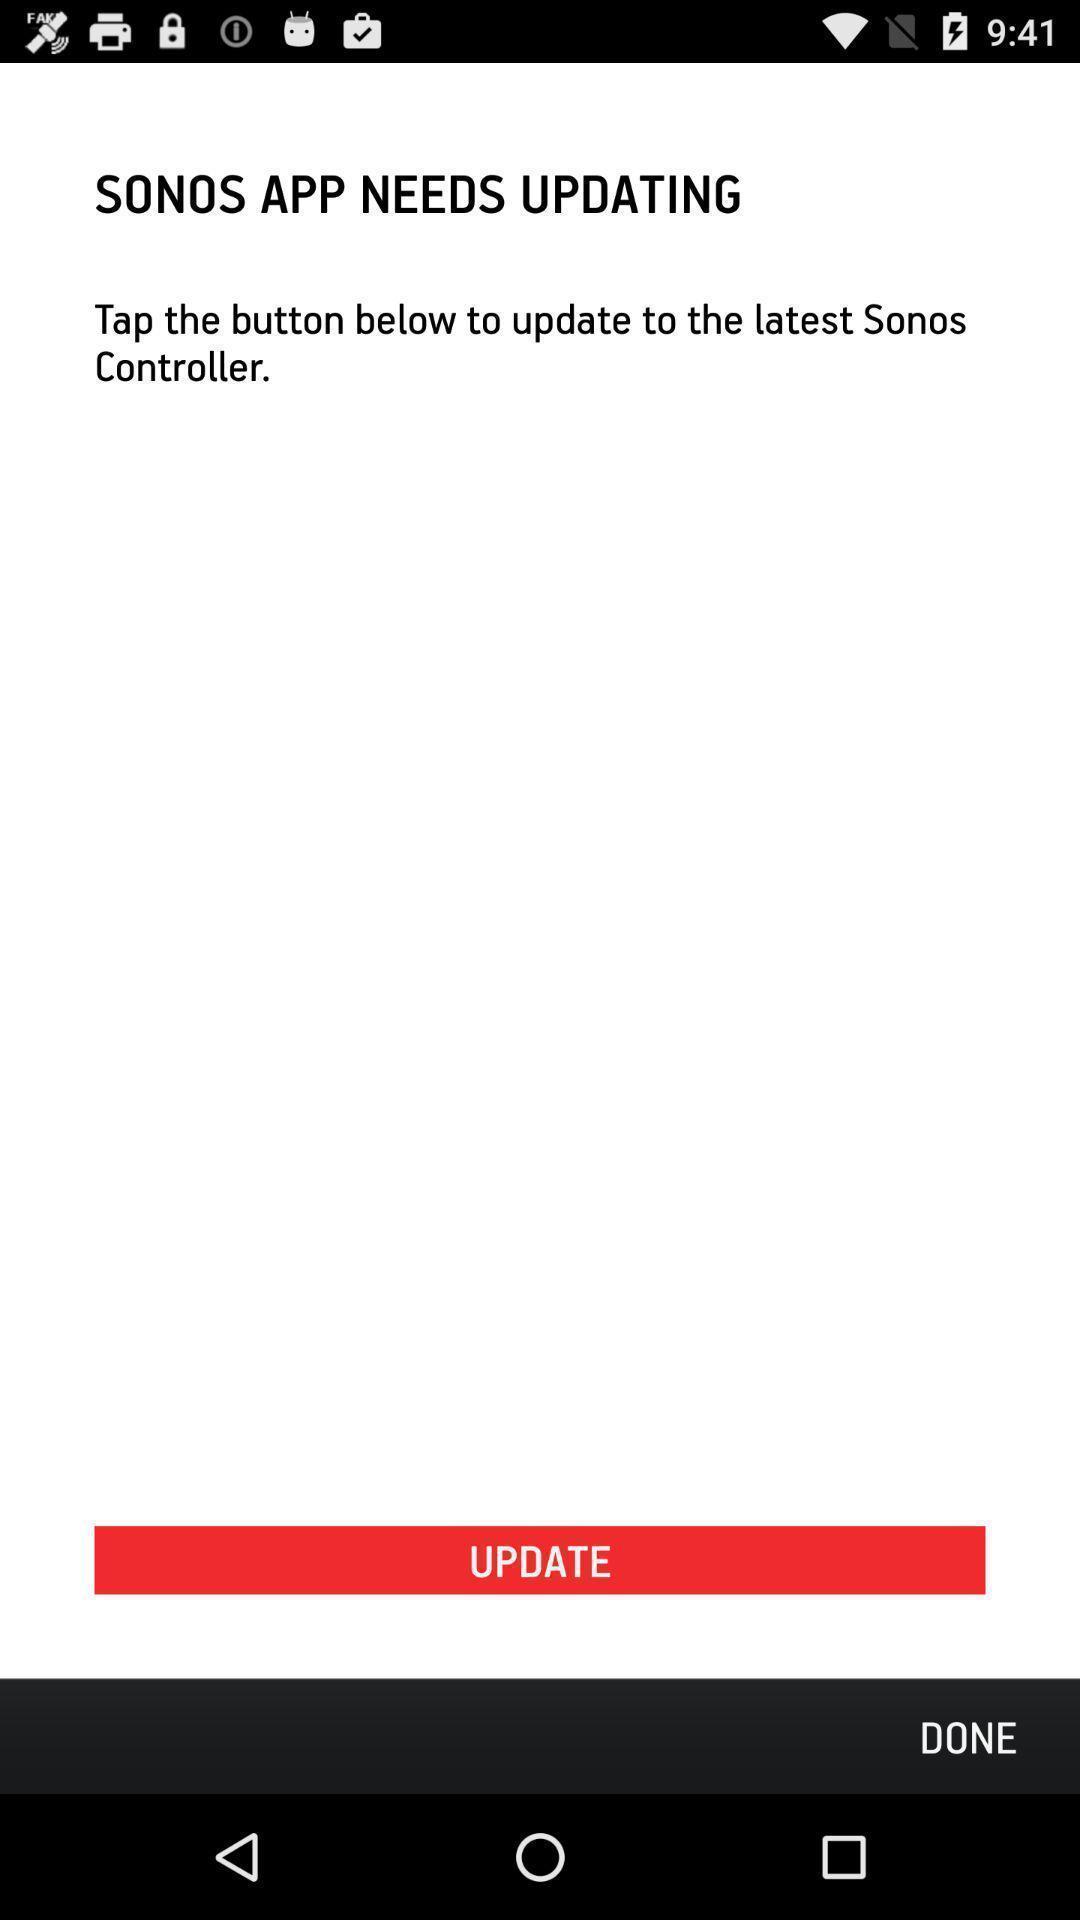Describe this image in words. Upgrade page of audio app. 